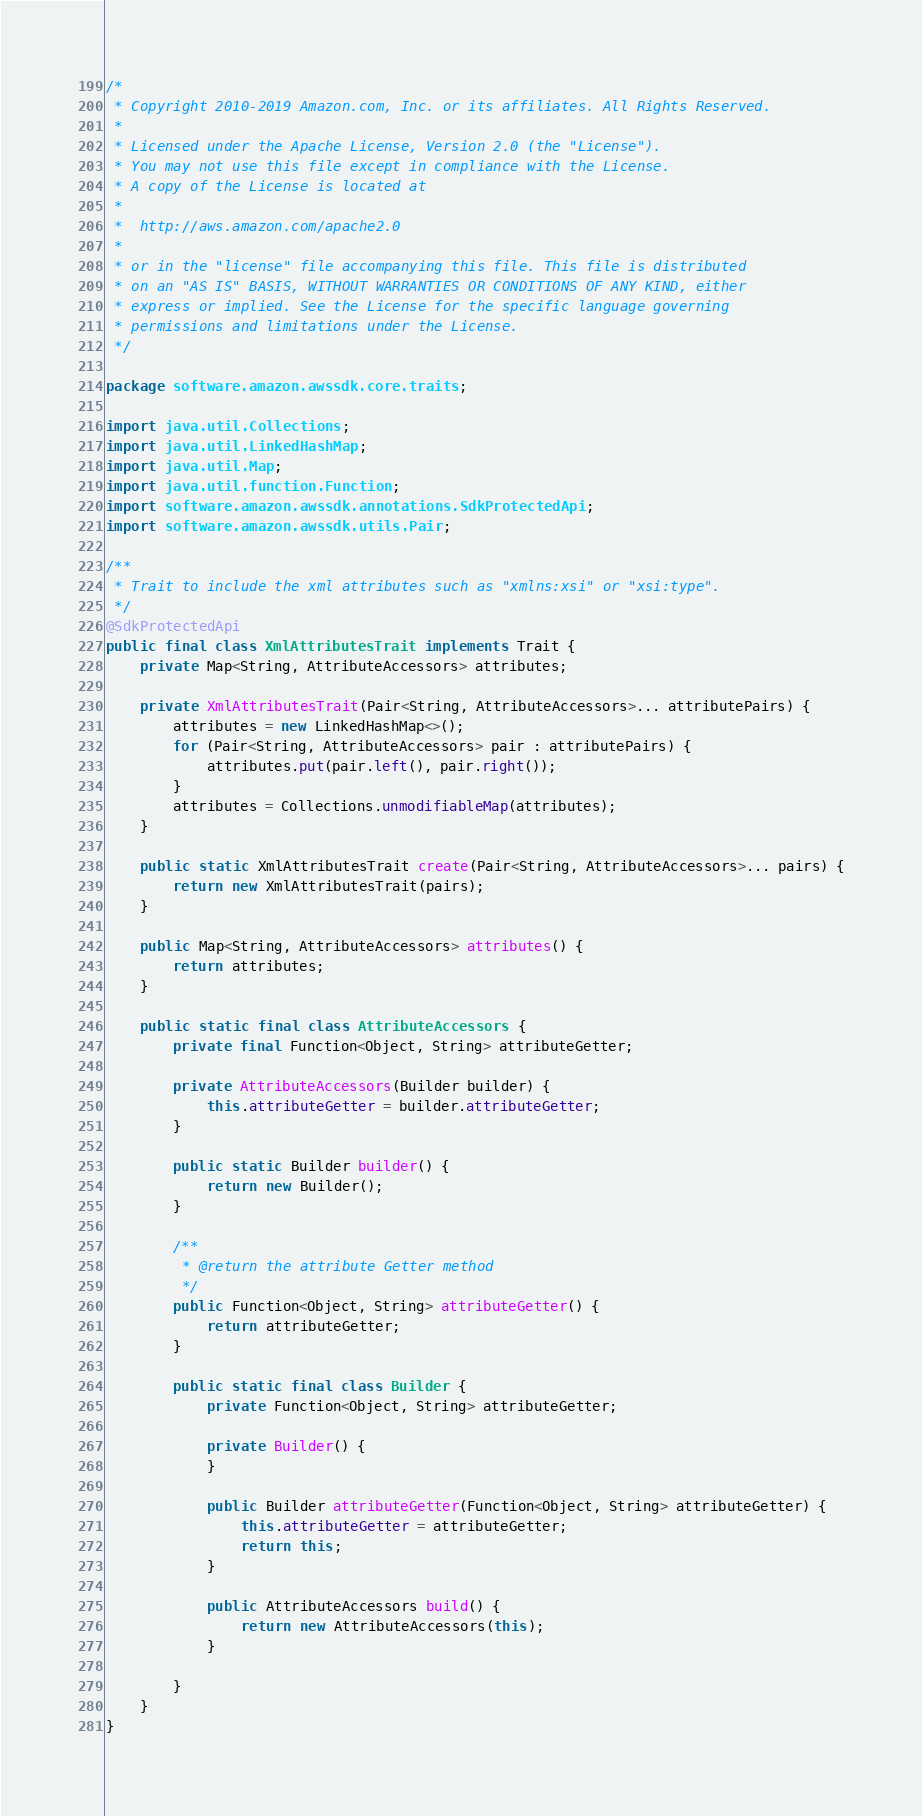Convert code to text. <code><loc_0><loc_0><loc_500><loc_500><_Java_>/*
 * Copyright 2010-2019 Amazon.com, Inc. or its affiliates. All Rights Reserved.
 *
 * Licensed under the Apache License, Version 2.0 (the "License").
 * You may not use this file except in compliance with the License.
 * A copy of the License is located at
 *
 *  http://aws.amazon.com/apache2.0
 *
 * or in the "license" file accompanying this file. This file is distributed
 * on an "AS IS" BASIS, WITHOUT WARRANTIES OR CONDITIONS OF ANY KIND, either
 * express or implied. See the License for the specific language governing
 * permissions and limitations under the License.
 */

package software.amazon.awssdk.core.traits;

import java.util.Collections;
import java.util.LinkedHashMap;
import java.util.Map;
import java.util.function.Function;
import software.amazon.awssdk.annotations.SdkProtectedApi;
import software.amazon.awssdk.utils.Pair;

/**
 * Trait to include the xml attributes such as "xmlns:xsi" or "xsi:type".
 */
@SdkProtectedApi
public final class XmlAttributesTrait implements Trait {
    private Map<String, AttributeAccessors> attributes;

    private XmlAttributesTrait(Pair<String, AttributeAccessors>... attributePairs) {
        attributes = new LinkedHashMap<>();
        for (Pair<String, AttributeAccessors> pair : attributePairs) {
            attributes.put(pair.left(), pair.right());
        }
        attributes = Collections.unmodifiableMap(attributes);
    }

    public static XmlAttributesTrait create(Pair<String, AttributeAccessors>... pairs) {
        return new XmlAttributesTrait(pairs);
    }

    public Map<String, AttributeAccessors> attributes() {
        return attributes;
    }

    public static final class AttributeAccessors {
        private final Function<Object, String> attributeGetter;

        private AttributeAccessors(Builder builder) {
            this.attributeGetter = builder.attributeGetter;
        }

        public static Builder builder() {
            return new Builder();
        }

        /**
         * @return the attribute Getter method
         */
        public Function<Object, String> attributeGetter() {
            return attributeGetter;
        }

        public static final class Builder {
            private Function<Object, String> attributeGetter;

            private Builder() {
            }

            public Builder attributeGetter(Function<Object, String> attributeGetter) {
                this.attributeGetter = attributeGetter;
                return this;
            }

            public AttributeAccessors build() {
                return new AttributeAccessors(this);
            }

        }
    }
}
</code> 